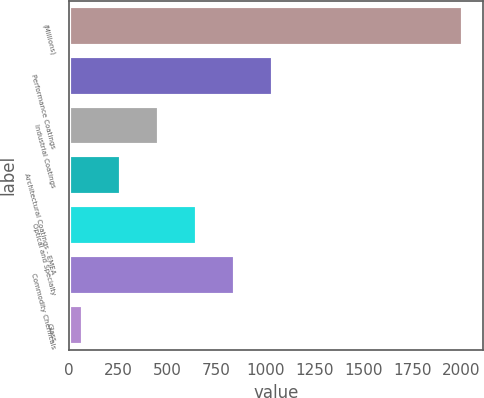Convert chart. <chart><loc_0><loc_0><loc_500><loc_500><bar_chart><fcel>(Millions)<fcel>Performance Coatings<fcel>Industrial Coatings<fcel>Architectural Coatings - EMEA<fcel>Optical and Specialty<fcel>Commodity Chemicals<fcel>Glass<nl><fcel>2008<fcel>1039<fcel>457.6<fcel>263.8<fcel>651.4<fcel>845.2<fcel>70<nl></chart> 